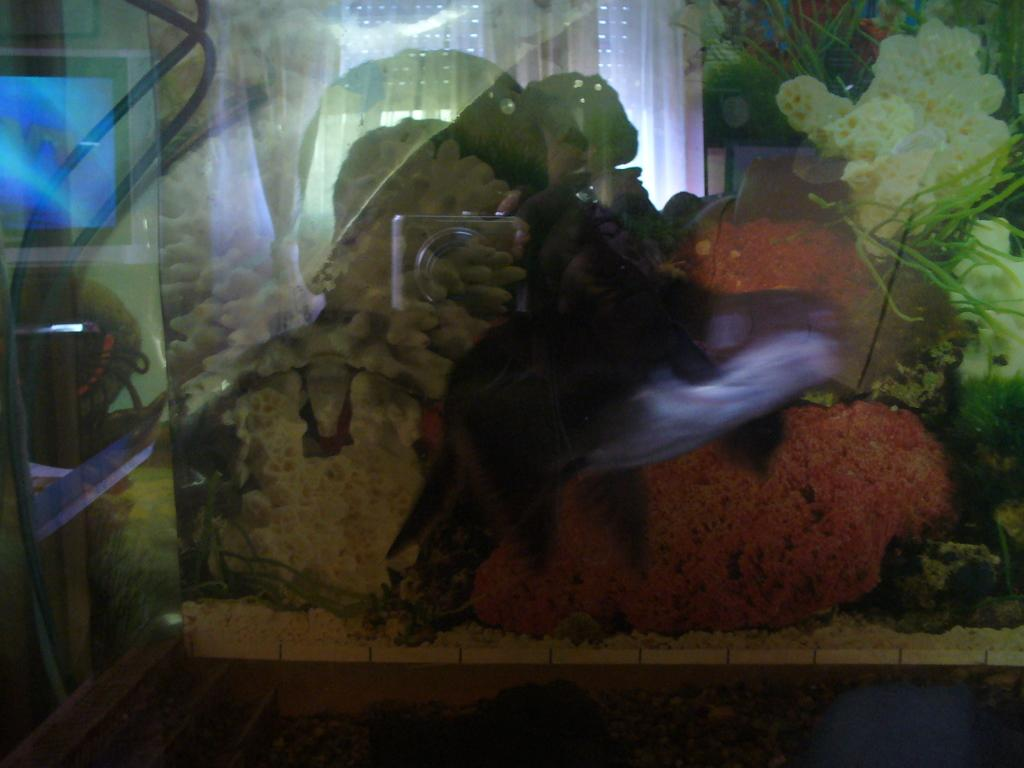What is the main subject of the picture? The main subject of the picture is an aquarium. What can be found inside the aquarium? The aquarium contains stones and fishes. Is there any reflection visible in the picture? Yes, there is a reflection visible on the aquarium glass. What type of creature can be seen climbing the trees in the image? There are no trees present in the image, so no creature can be seen climbing them. 